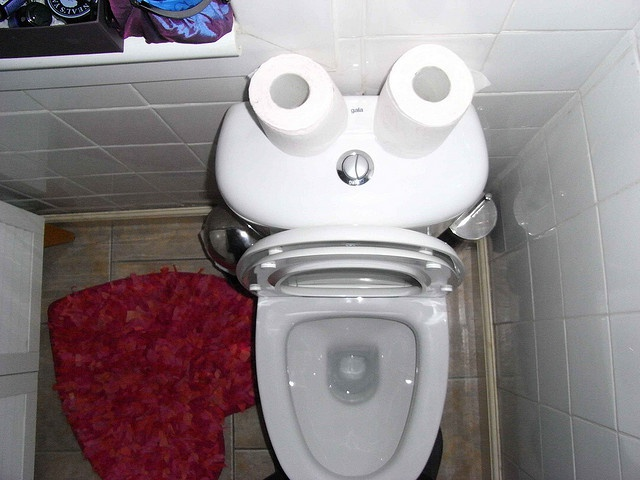Describe the objects in this image and their specific colors. I can see a toilet in darkgray, white, gray, and black tones in this image. 